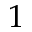Convert formula to latex. <formula><loc_0><loc_0><loc_500><loc_500>1</formula> 